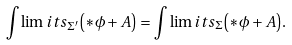Convert formula to latex. <formula><loc_0><loc_0><loc_500><loc_500>\int \lim i t s _ { \Sigma ^ { \prime } } { \left ( { * \phi + A } \right ) } = \int \lim i t s _ { \Sigma } { \left ( { * \phi + A } \right ) } .</formula> 